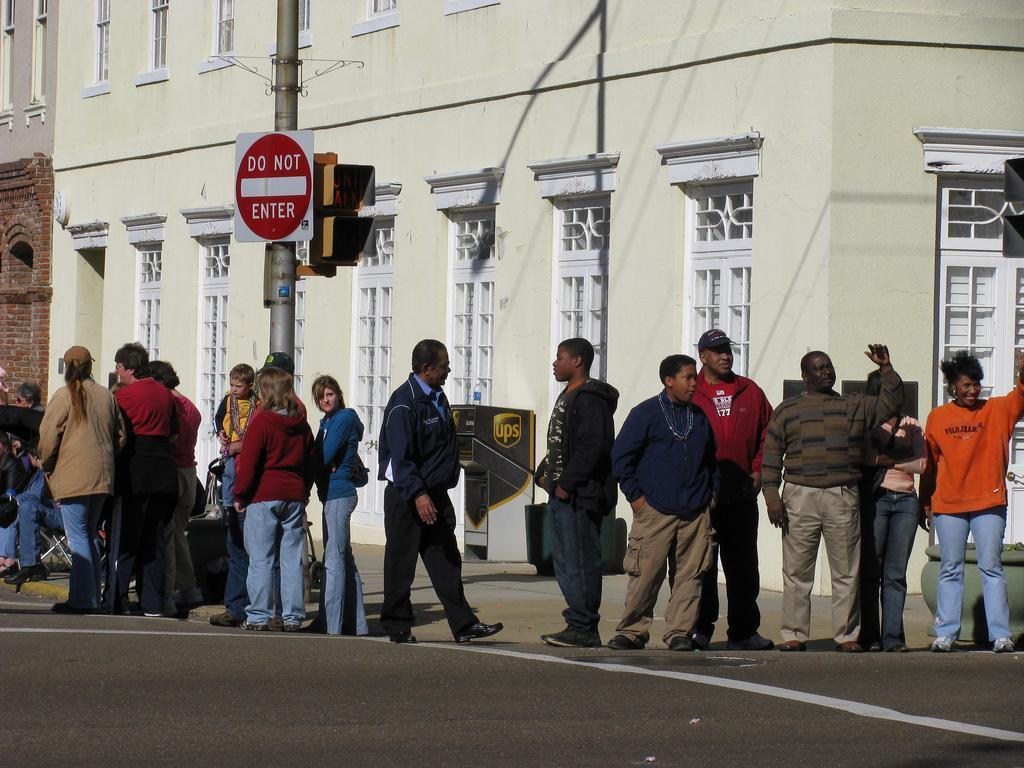How many people are wearing red?
Give a very brief answer. 3. How many people are wearing hats?
Give a very brief answer. 2. How many signs are there?
Give a very brief answer. 1. How many children are in the scene?
Give a very brief answer. 1. How many men wearing a black sweatshirt?
Give a very brief answer. 1. How many Do Not Enter signs are there?
Give a very brief answer. 1. How many people are waving arms in the air?
Give a very brief answer. 2. 